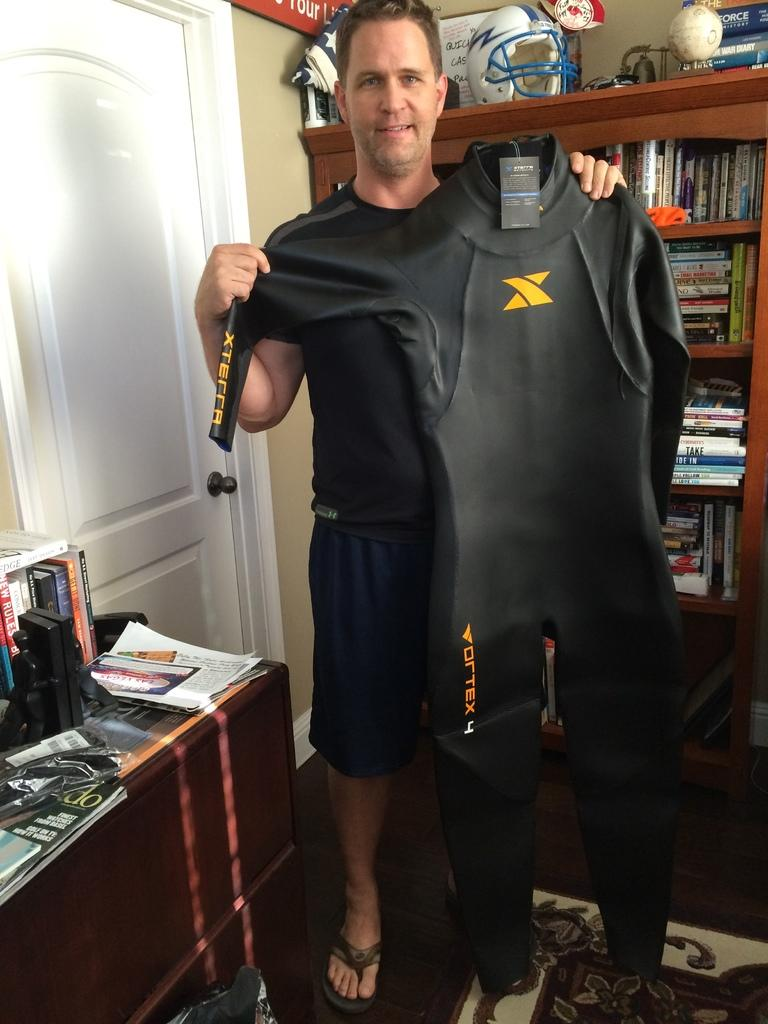<image>
Create a compact narrative representing the image presented. A man holding a diving suit that has Vortex 4 written on it. 